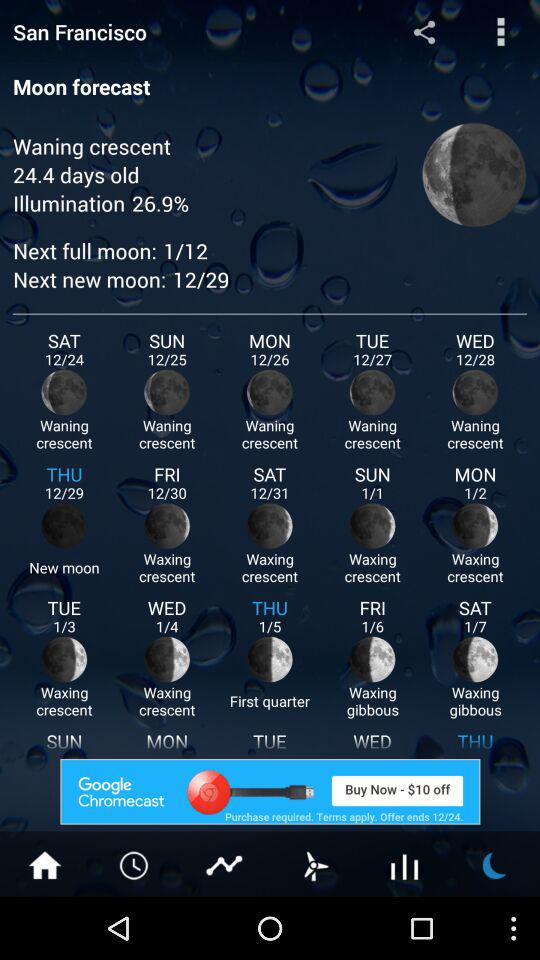What is the day on December 29? The day is Thursday. 